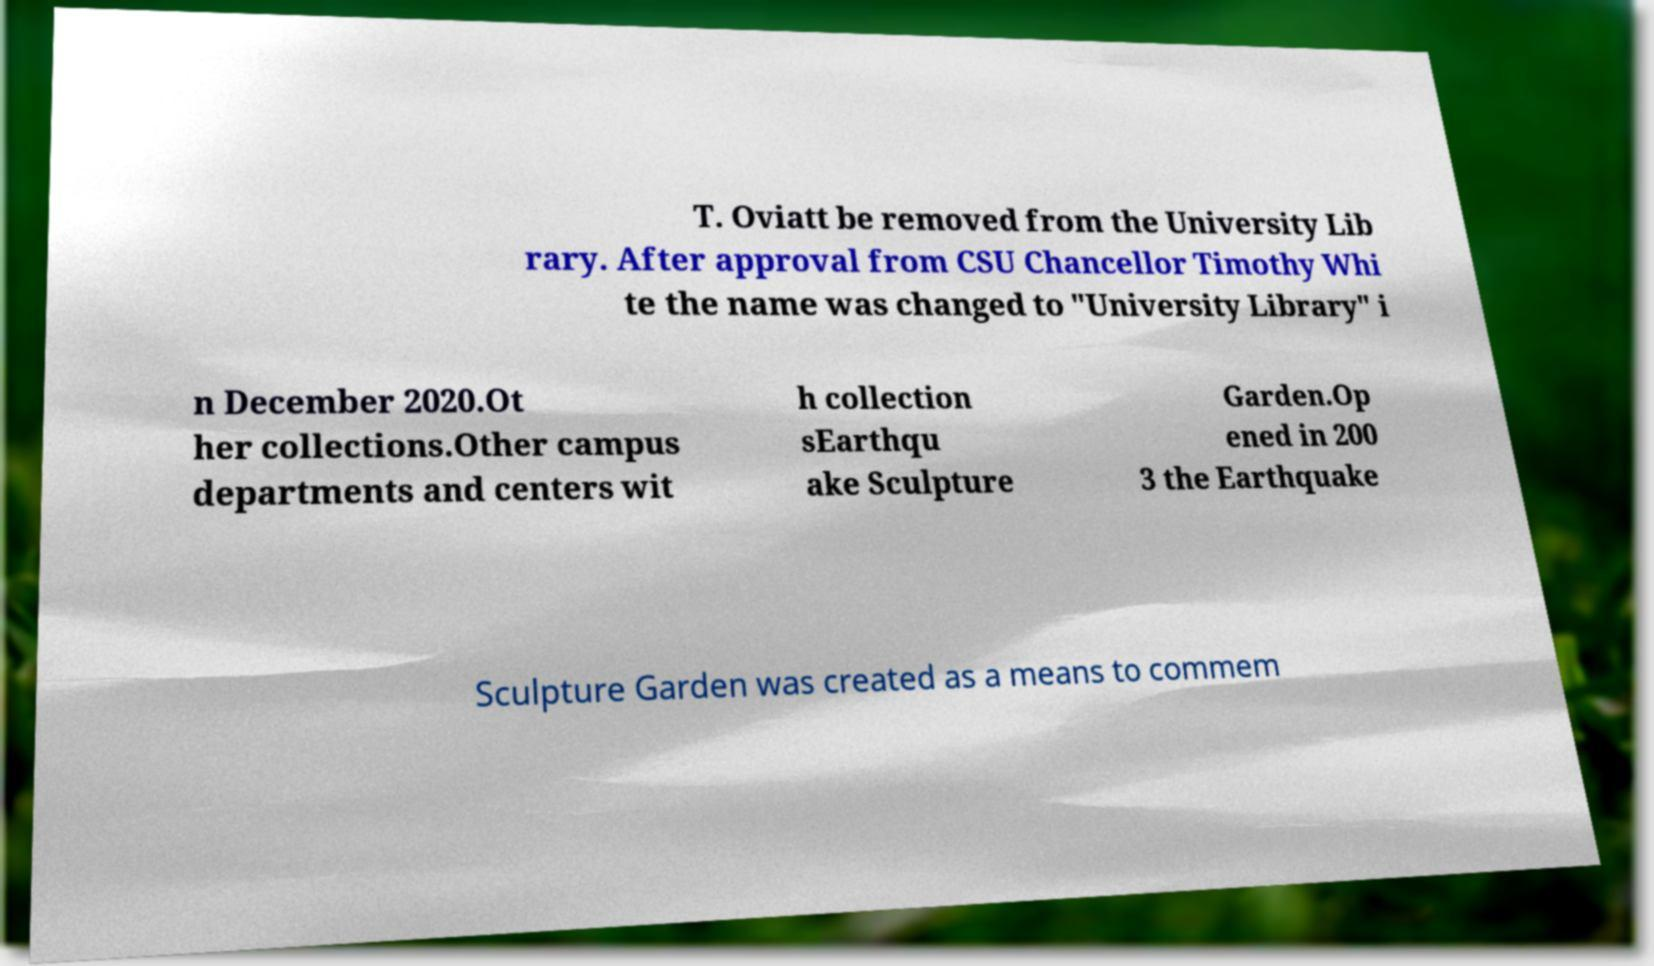Please read and relay the text visible in this image. What does it say? T. Oviatt be removed from the University Lib rary. After approval from CSU Chancellor Timothy Whi te the name was changed to "University Library" i n December 2020.Ot her collections.Other campus departments and centers wit h collection sEarthqu ake Sculpture Garden.Op ened in 200 3 the Earthquake Sculpture Garden was created as a means to commem 